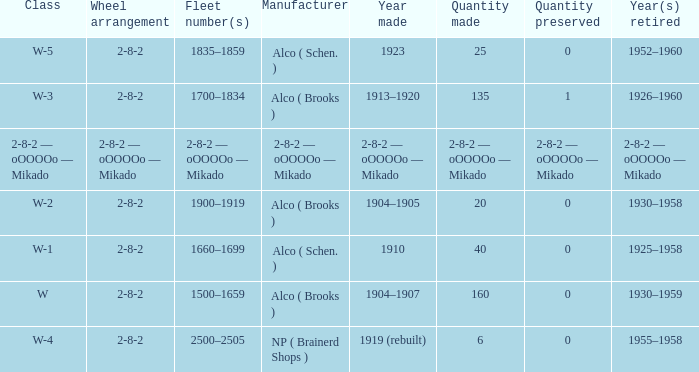In which year was the locomotive, with 25 units produced, retired? 1952–1960. 